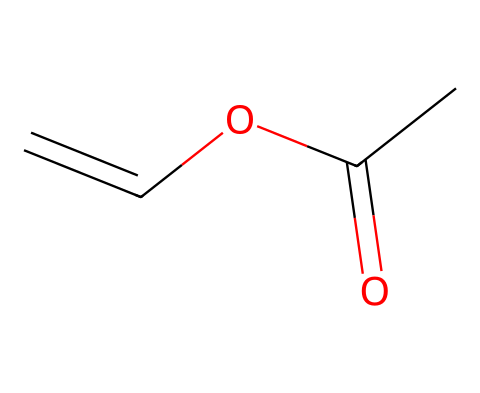What is the molecular formula of vinyl acetate monomer? To find the molecular formula, count the atoms present in the SMILES representation CC(=O)OC=C. There are 4 carbon (C) atoms, 6 hydrogen (H) atoms, and 2 oxygen (O) atoms. Thus, the molecular formula is C4H6O2.
Answer: C4H6O2 How many double bonds are present in the structure? In the SMILES CC(=O)OC=C, there is a carbon-carbon double bond (indicated by the '=' after the first C) and a carbon-oxygen double bond (indicated by the '=' after C), making a total of 2 double bonds.
Answer: 2 What type of functional group is present in vinyl acetate? The chemical structure shows a carbonyl group (C=O) and an ester functional group (–O–C), indicating that it is an ester. This can be identified by the presence of the –COOC– pattern in the structure.
Answer: ester What is the total number of hydrogen atoms in the compound? By noting the hydrogen atoms connected to each carbon in the structure and the hydrogen associated with the carbon in the carbonyl group, we calculate the total to be 6 from the formula C4H6O2.
Answer: 6 Is vinyl acetate a photoreactive compound? Vinyl acetate is classified as a photoreactive compound due to its ability to undergo chemical changes when exposed to light, particularly because of the presence of double bonds in the structure, which are susceptible to photochemical reactions.
Answer: yes How many atoms of oxygen are present in vinyl acetate? The SMILES representation shows two oxygen atoms (O) in the formula C4H6O2, which is confirmed by a direct view of the structure where both occurrences can be seen.
Answer: 2 